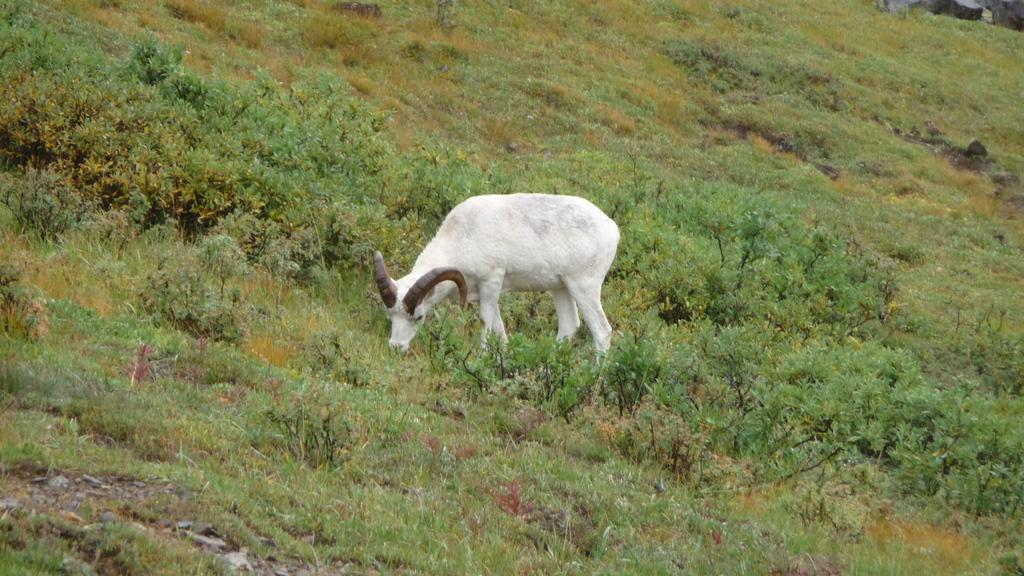What type of animal is in the image? There is a wild sheep in the image. What is the sheep doing in the image? The sheep is standing and eating grass. What can be seen in the background of the image? There are plants in the background of the image. How many times has the sheep experienced death in the image? A: The concept of death does not apply to the sheep in the image, as it is a living animal. 